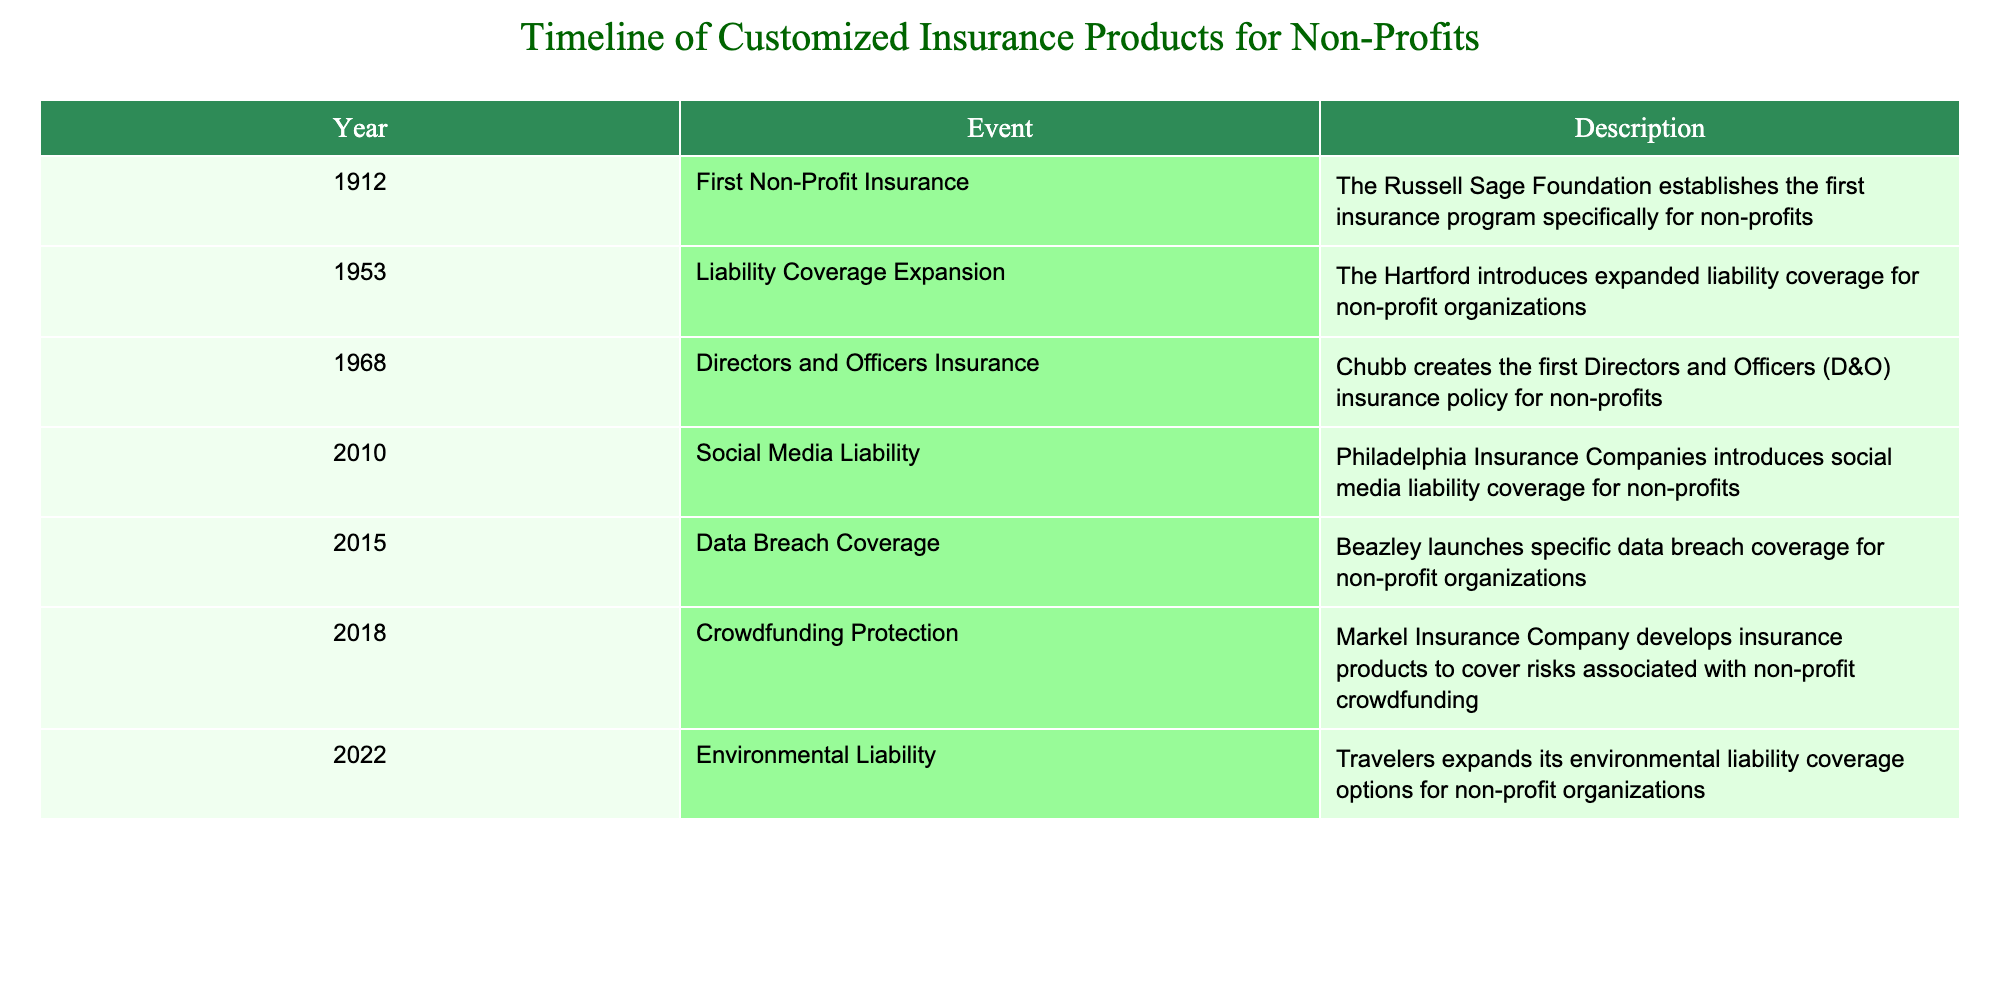What year did the Russell Sage Foundation establish the first non-profit insurance program? The table lists the event and its corresponding year. The first entry shows that the Russell Sage Foundation established the first non-profit insurance in 1912.
Answer: 1912 Which company introduced expanded liability coverage for non-profit organizations? By scanning the table, we find that the Hartford is the company that introduced the expanded liability coverage in 1953.
Answer: The Hartford What new type of insurance coverage was introduced in 2015? Looking at the 2015 entry of the table, it states that Beazley launched specific data breach coverage for non-profit organizations.
Answer: Data breach coverage Did Chubb create the first Directors and Officers insurance policy for non-profits before 1970? The table indicates that Chubb created the first Directors and Officers insurance policy in 1968, which is before 1970, making the statement true.
Answer: Yes What is the difference in years between the introduction of social media liability coverage and crowdfunding protection? Social media liability coverage was introduced in 2010 and crowdfunding protection in 2018. To find the difference, subtract 2010 from 2018, resulting in 8 years.
Answer: 8 years How many events occurred in the 2010s? The table shows five events: in 2010, 2015, and 2018. Counting those gives a total of three events during the 2010s.
Answer: 3 events Was the first non-profit insurance program established after the introduction of environmental liability coverage? The first non-profit insurance program was established in 1912, while environmental liability coverage was expanded in 2022, thus the establishment occurred significantly earlier than the coverage's expansion.
Answer: No Identify the company responsible for developing insurance products for non-profit crowdfunding and describe its event's year. The table shows Markel Insurance Company developing insurance products for crowdfunding in 2018, specifically focused on the associated risks.
Answer: Markel Insurance Company in 2018 What was the trend in non-profit insurance development from 1912 to 2022? The timeline indicates a steady development of customized insurance products for non-profits, showing an expansion in types of risks covered, from basic insurance in 1912 to specialized coverages like environmental liability by 2022. This reflects a growing recognition of the diverse risks faced by non-profits over time.
Answer: Steady expansion of coverage types 